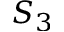<formula> <loc_0><loc_0><loc_500><loc_500>S _ { 3 }</formula> 